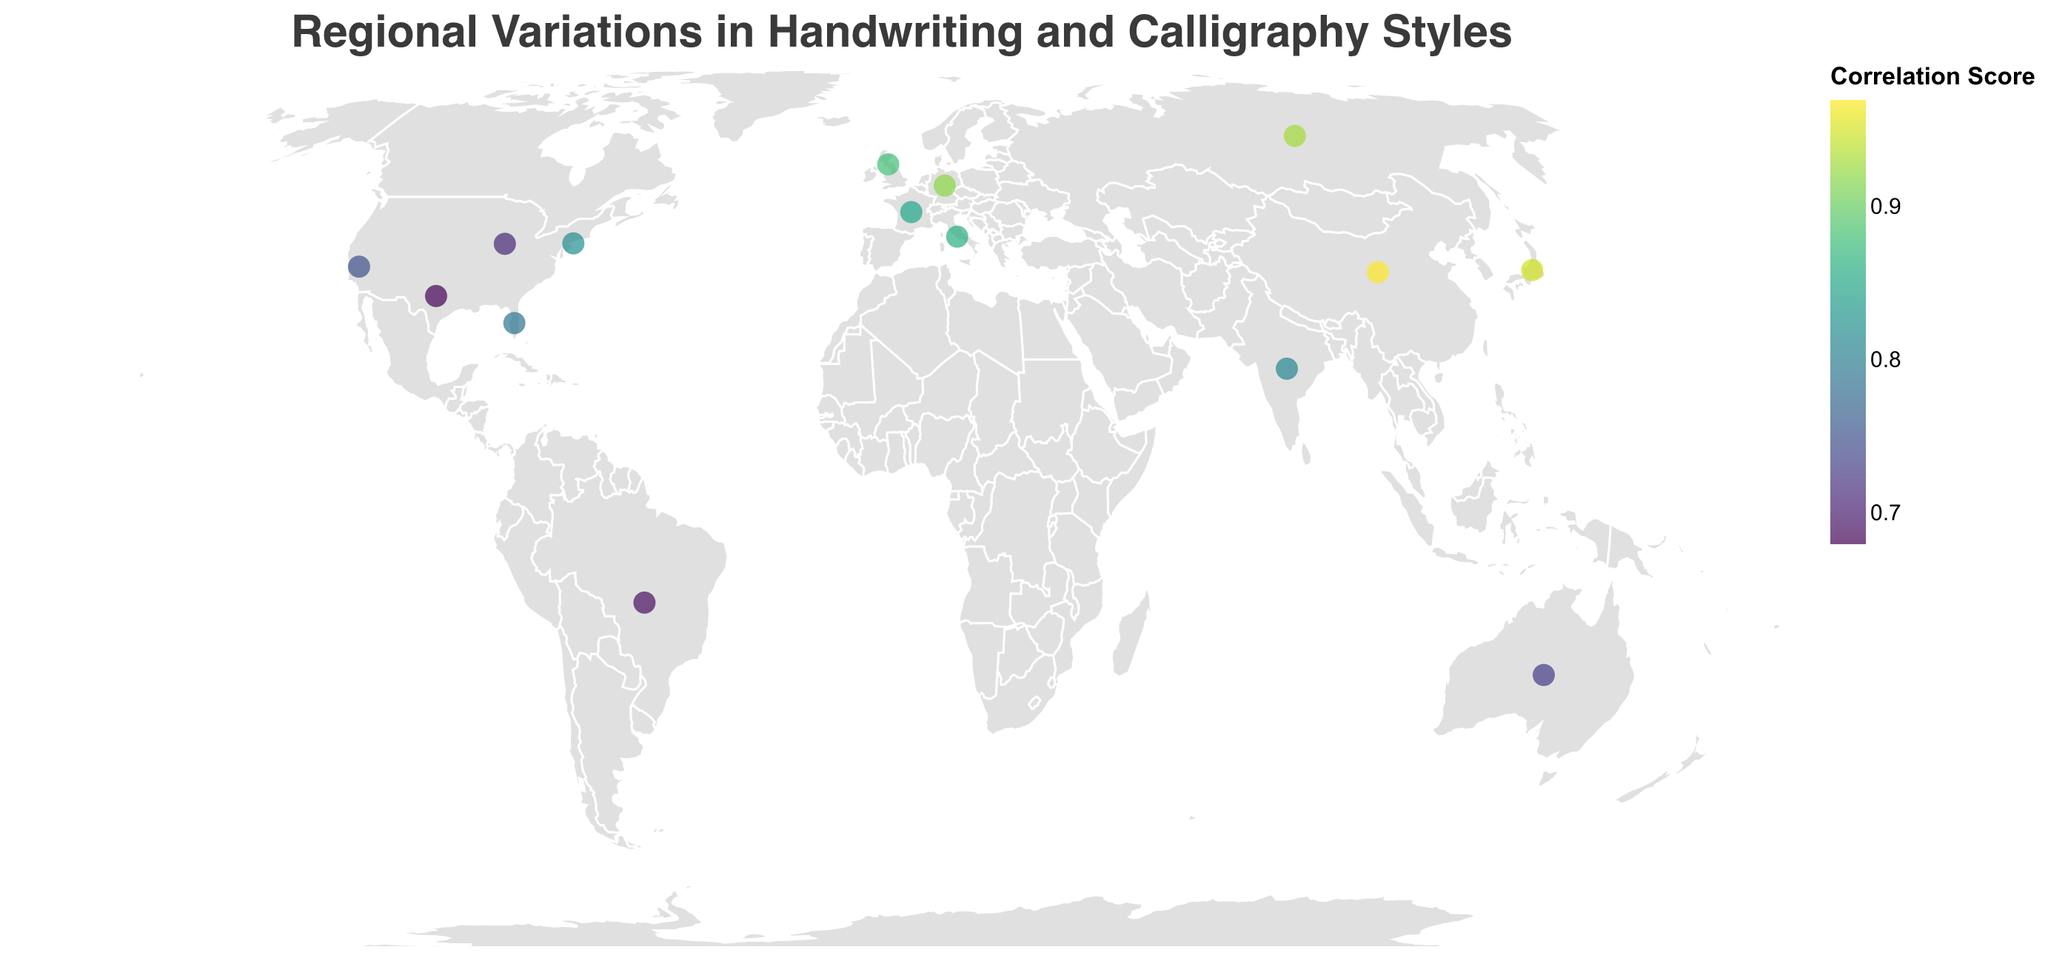What is the calligraphy style that has the highest correlation score in this figure? Look at the circle with the highest correlation score. The tooltip will indicate the calligraphy style with that score.
Answer: Kaishu Which region's dominant handwriting style is 'Devnagari-influenced' and what is their popular calligraphy style? Locate the region with the 'Devnagari-influenced' handwriting style on the map. Check the tooltip for the popular calligraphy style.
Answer: India, Arabic Calligraphy Which two regions have a correlation score higher than 0.9 and what are their popular calligraphy styles? Identify circles with correlation scores higher than 0.9. Check the tooltips for the popular calligraphy styles of these regions.
Answer: Germany (Fraktur), Russia (Vyaz) Compare the correlation scores for cursive handwriting styles in New York and Italy. Which is higher? Locate the points for New York and Italy. Compare their correlation scores.
Answer: New York has a higher correlation score (0.82 vs. 0.86 for Italy) What is the median correlation score among all the regions? List all the correlation scores: 0.82, 0.75, 0.68, 0.79, 0.71, 0.88, 0.85, 0.92, 0.95, 0.97, 0.73, 0.81, 0.69, 0.93, 0.86. Arrange them in ascending order: 0.68, 0.69, 0.71, 0.73, 0.75, 0.79, 0.81, 0.82, 0.85, 0.86, 0.88, 0.92, 0.93, 0.95, 0.97. The median is the middle number in this ordered list.
Answer: 0.82 Which region has the least common handwriting style on the map and what is the handwriting style? Identify the region with the handwriting style that appears unique on the map. Check the tooltip for its style.
Answer: Japan, Kanji-based How many different dominant handwriting styles are displayed in this figure? Count the number of unique handwriting styles shown on the map.
Answer: 10 Which region's popular calligraphy style is ‘Copperplate’ and what is their correlation score? Locate the region where the popular calligraphy style is 'Copperplate' on the map. Check the tooltip for its correlation score.
Answer: California, 0.75 What is the average correlation score for all regions with 'Mixed' handwriting styles? Identify the regions with 'Mixed' handwriting styles. Sum their correlation scores and divide by the number of these regions (Brazil and Texas).
Answer: (0.69 + 0.68) / 2 = 0.685 